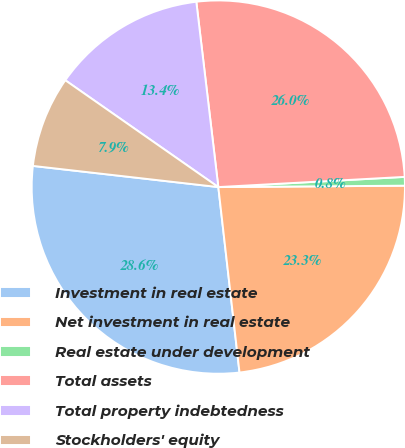Convert chart to OTSL. <chart><loc_0><loc_0><loc_500><loc_500><pie_chart><fcel>Investment in real estate<fcel>Net investment in real estate<fcel>Real estate under development<fcel>Total assets<fcel>Total property indebtedness<fcel>Stockholders' equity<nl><fcel>28.62%<fcel>23.31%<fcel>0.75%<fcel>26.01%<fcel>13.42%<fcel>7.89%<nl></chart> 